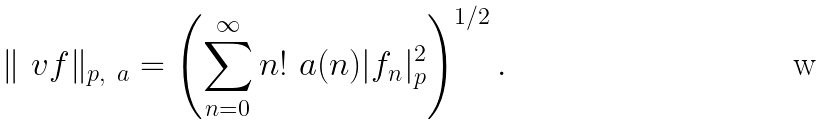<formula> <loc_0><loc_0><loc_500><loc_500>\| \ v f \| _ { p , \ a } = \left ( \sum _ { n = 0 } ^ { \infty } n ! \ a ( n ) | f _ { n } | _ { p } ^ { 2 } \right ) ^ { 1 / 2 } .</formula> 